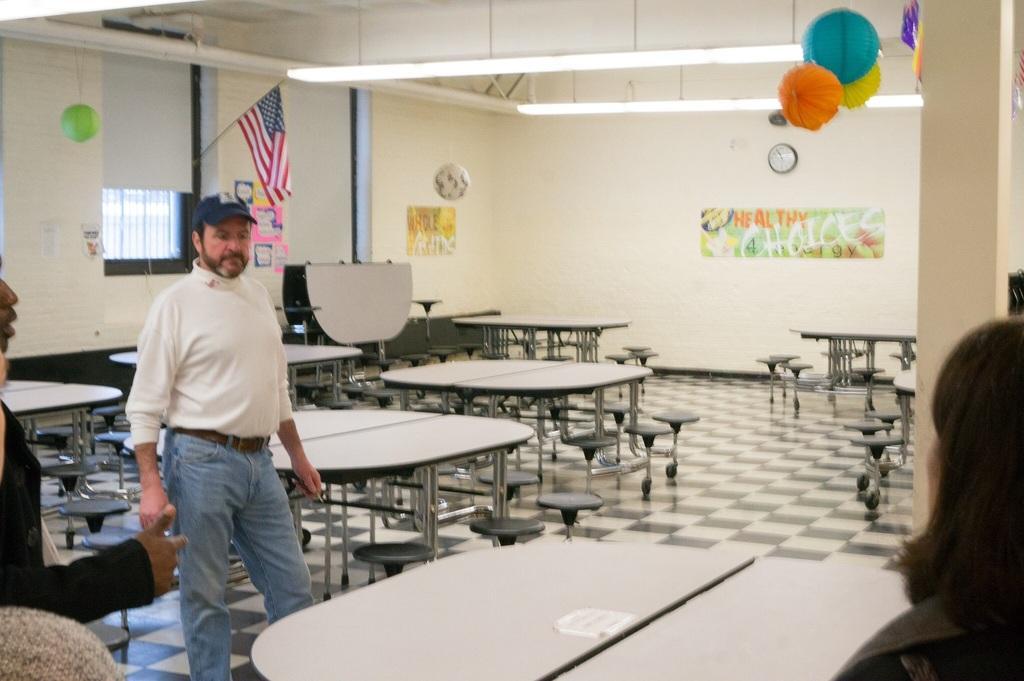Describe this image in one or two sentences. This image is clicked in a room where there are so many tables and stools. There is a flag on the top side, there are lights on the top, there are decorative items on the right side and left side. There are people standing. In this image the one who is standing on the left side is wearing a white color shirt and blue jeans. There is a poster attached to a wall and there is a clock on the wall. 